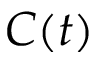Convert formula to latex. <formula><loc_0><loc_0><loc_500><loc_500>C ( t )</formula> 